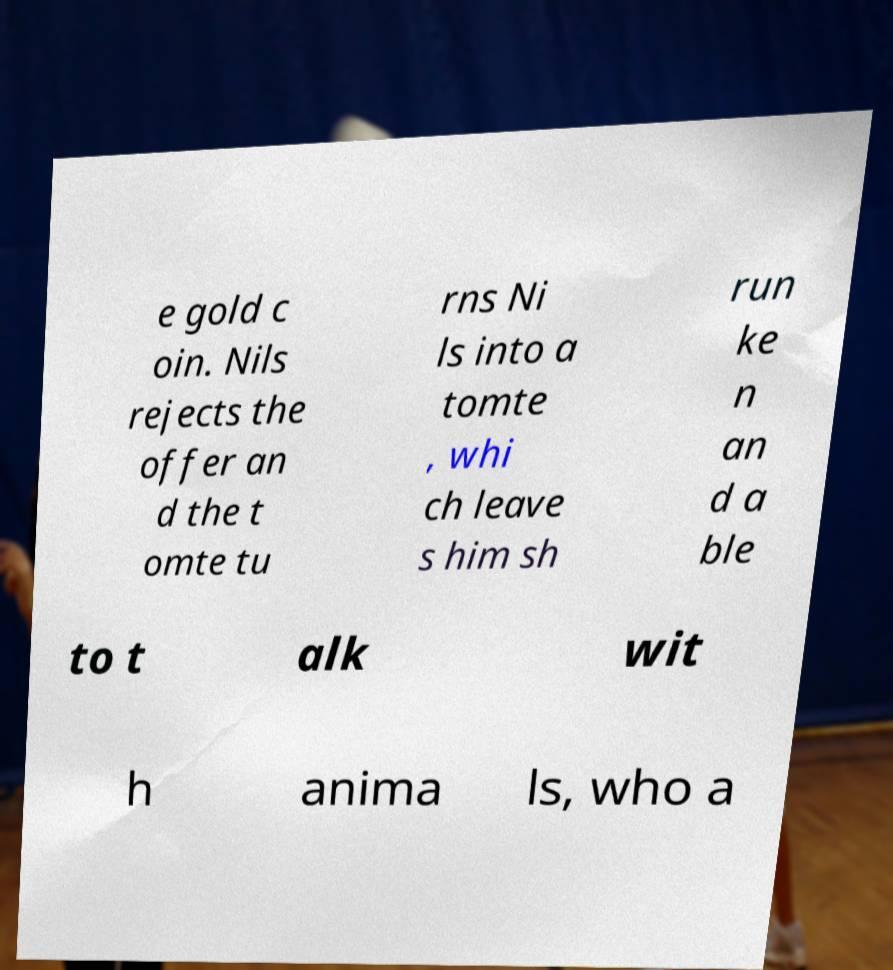Could you assist in decoding the text presented in this image and type it out clearly? e gold c oin. Nils rejects the offer an d the t omte tu rns Ni ls into a tomte , whi ch leave s him sh run ke n an d a ble to t alk wit h anima ls, who a 